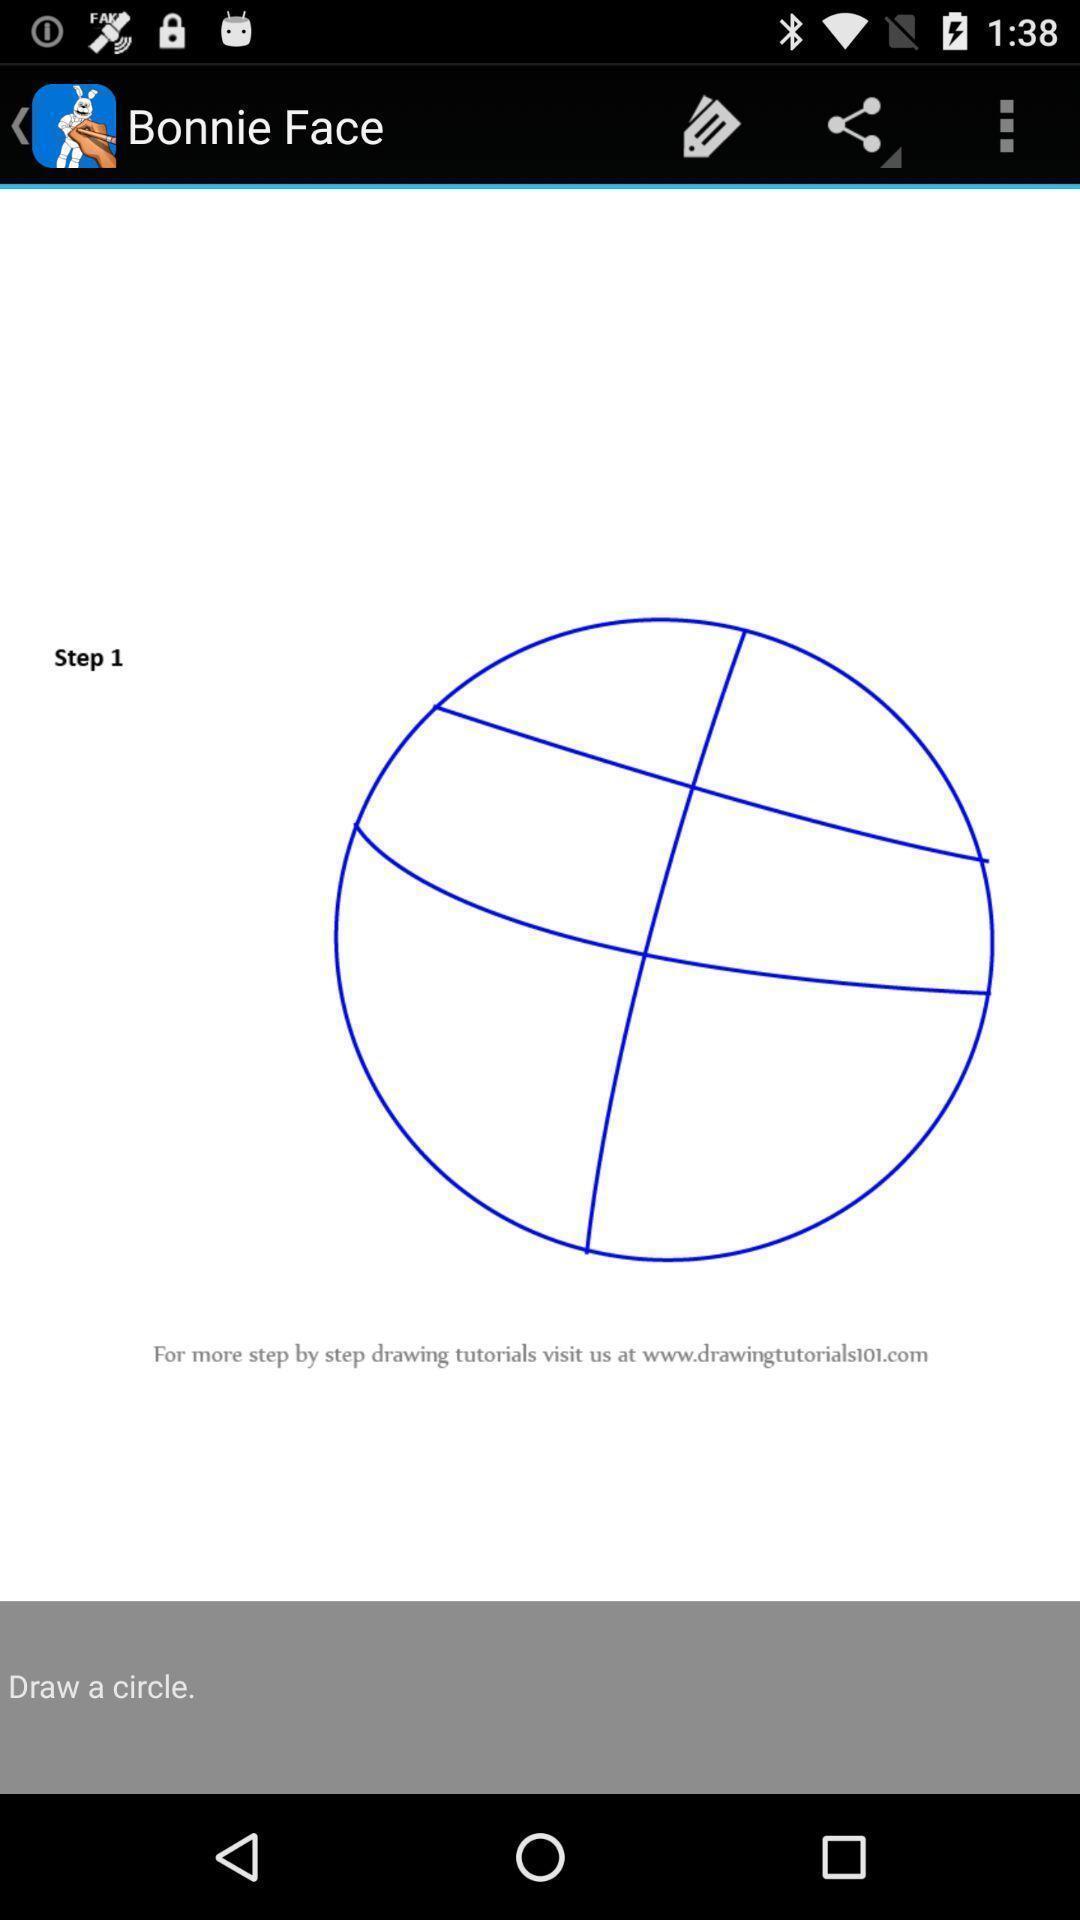Give me a narrative description of this picture. Screen displaying image of a circle. 